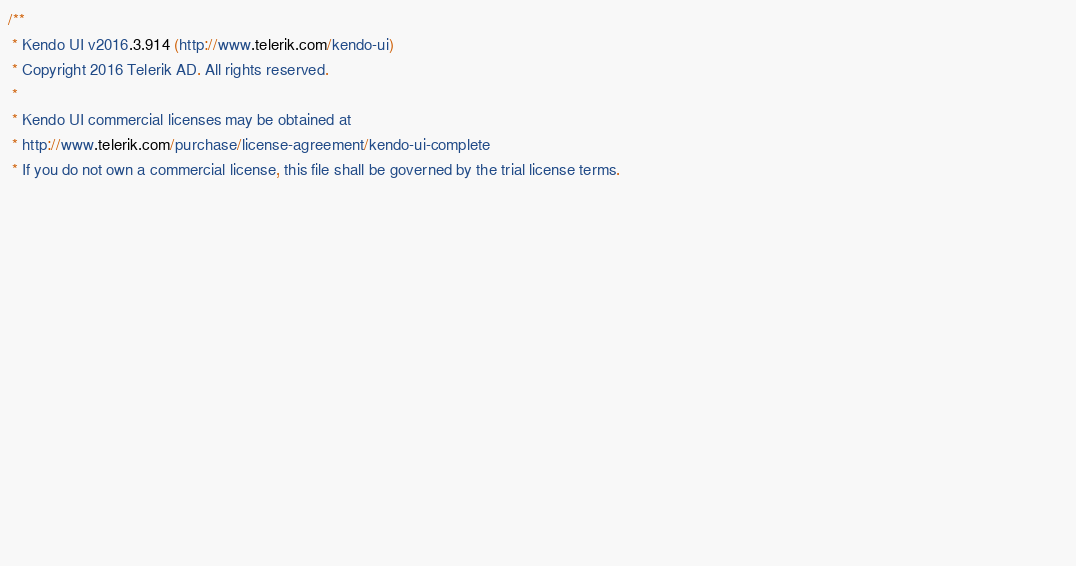<code> <loc_0><loc_0><loc_500><loc_500><_CSS_>/** 
 * Kendo UI v2016.3.914 (http://www.telerik.com/kendo-ui)                                                                                                                                               
 * Copyright 2016 Telerik AD. All rights reserved.                                                                                                                                                      
 *                                                                                                                                                                                                      
 * Kendo UI commercial licenses may be obtained at                                                                                                                                                      
 * http://www.telerik.com/purchase/license-agreement/kendo-ui-complete                                                                                                                                  
 * If you do not own a commercial license, this file shall be governed by the trial license terms.                                                                                                      
                                                                                                                                                                                                       
                                                                                                                                                                                                       
                                                                                                                                                                                                       
                                                                                                                                                                                                       
                                                                                                                                                                                                       
                                                                                                                                                                                                       
                                                                                                                                                                                                       
                                                                                                                                                                                                       
                                                                                                                                                                                                       
                                                                                                                                                                                                       
                                                                                                                                                                                                       
                                                                                                                                                                                                       
                                                                                                                                                                                                       
                                                                                                                                                                                                       
                                                                                                                                                                                                       
</code> 